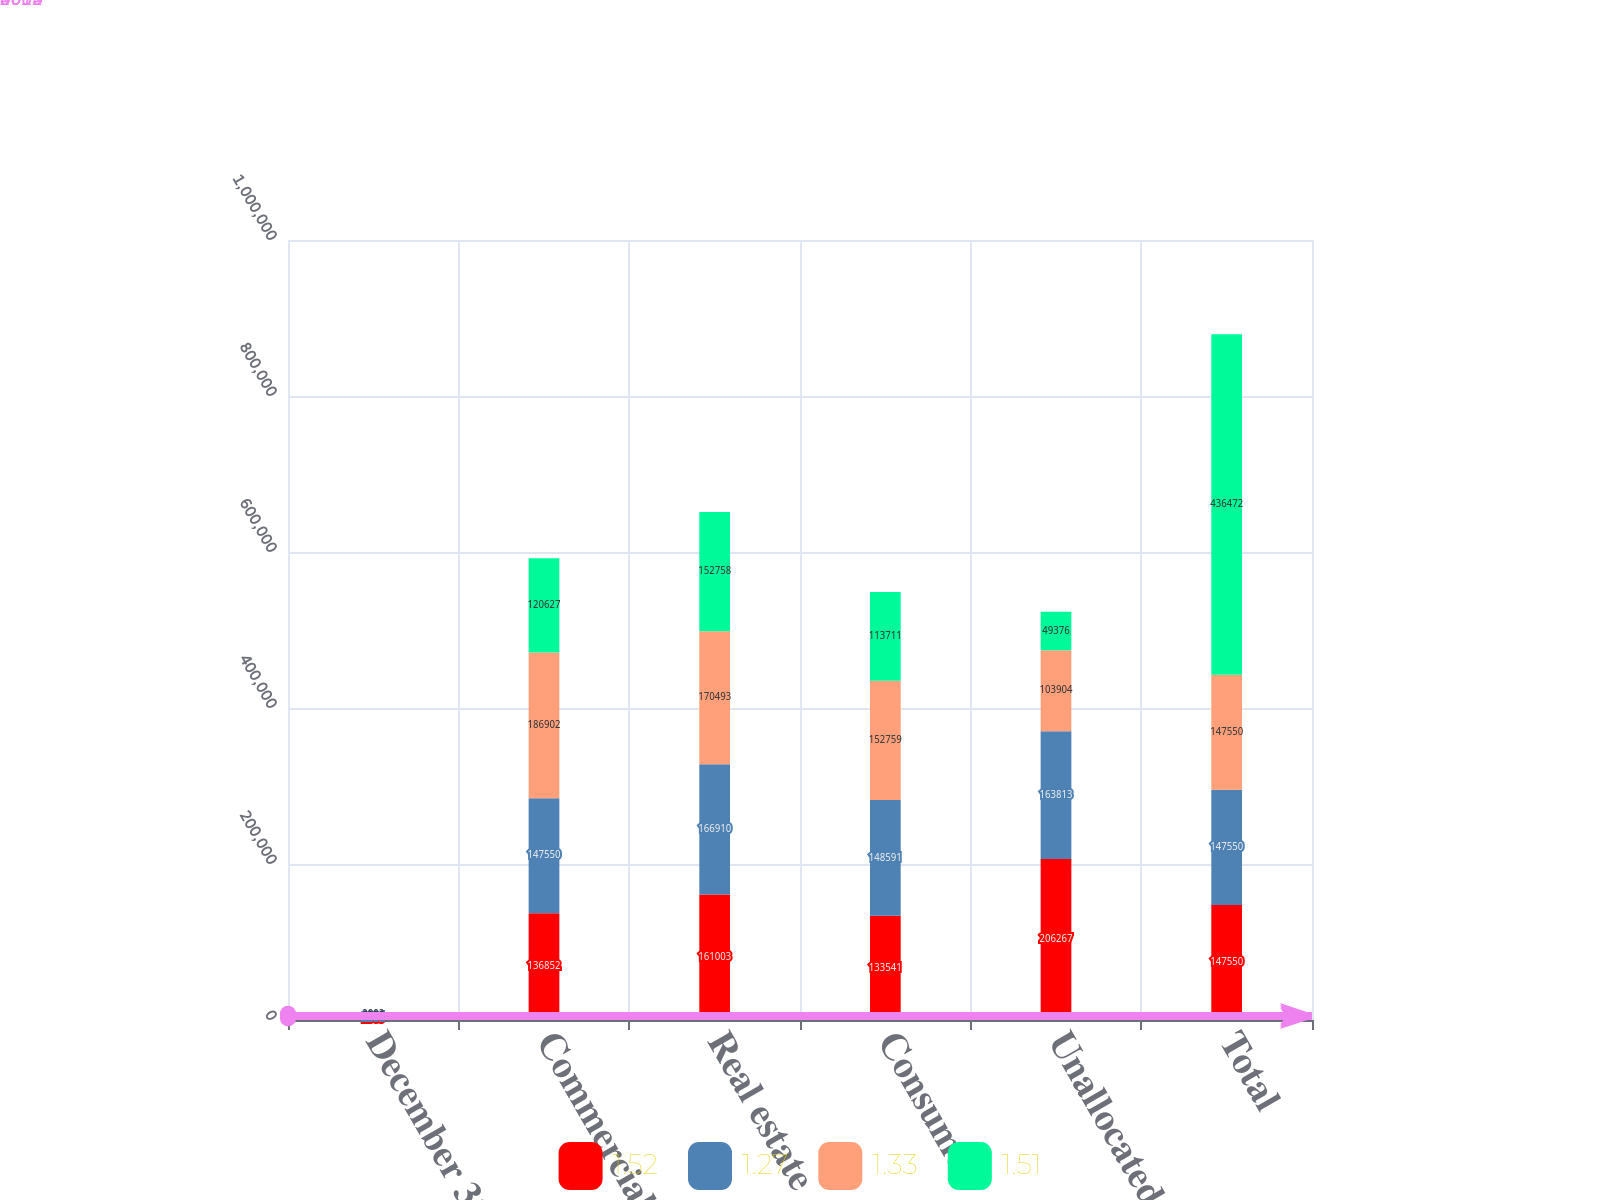Convert chart to OTSL. <chart><loc_0><loc_0><loc_500><loc_500><stacked_bar_chart><ecel><fcel>December 31<fcel>Commercial financial<fcel>Real estate<fcel>Consumer<fcel>Unallocated<fcel>Total<nl><fcel>1.52<fcel>2005<fcel>136852<fcel>161003<fcel>133541<fcel>206267<fcel>147550<nl><fcel>1.27<fcel>2004<fcel>147550<fcel>166910<fcel>148591<fcel>163813<fcel>147550<nl><fcel>1.33<fcel>2003<fcel>186902<fcel>170493<fcel>152759<fcel>103904<fcel>147550<nl><fcel>1.51<fcel>2002<fcel>120627<fcel>152758<fcel>113711<fcel>49376<fcel>436472<nl></chart> 